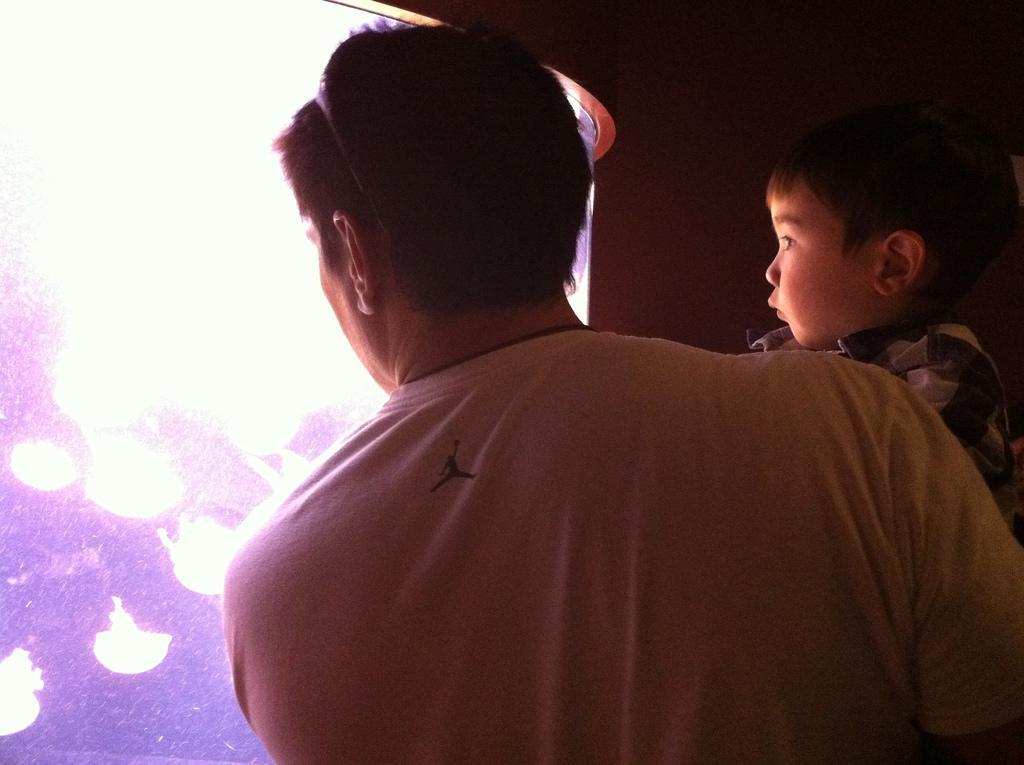Describe this image in one or two sentences. In the image there is a man holding a boy in his arms and it looks like there is an aquarium in front of them. 